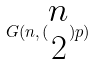Convert formula to latex. <formula><loc_0><loc_0><loc_500><loc_500>G ( n , ( \begin{matrix} n \\ 2 \end{matrix} ) p )</formula> 